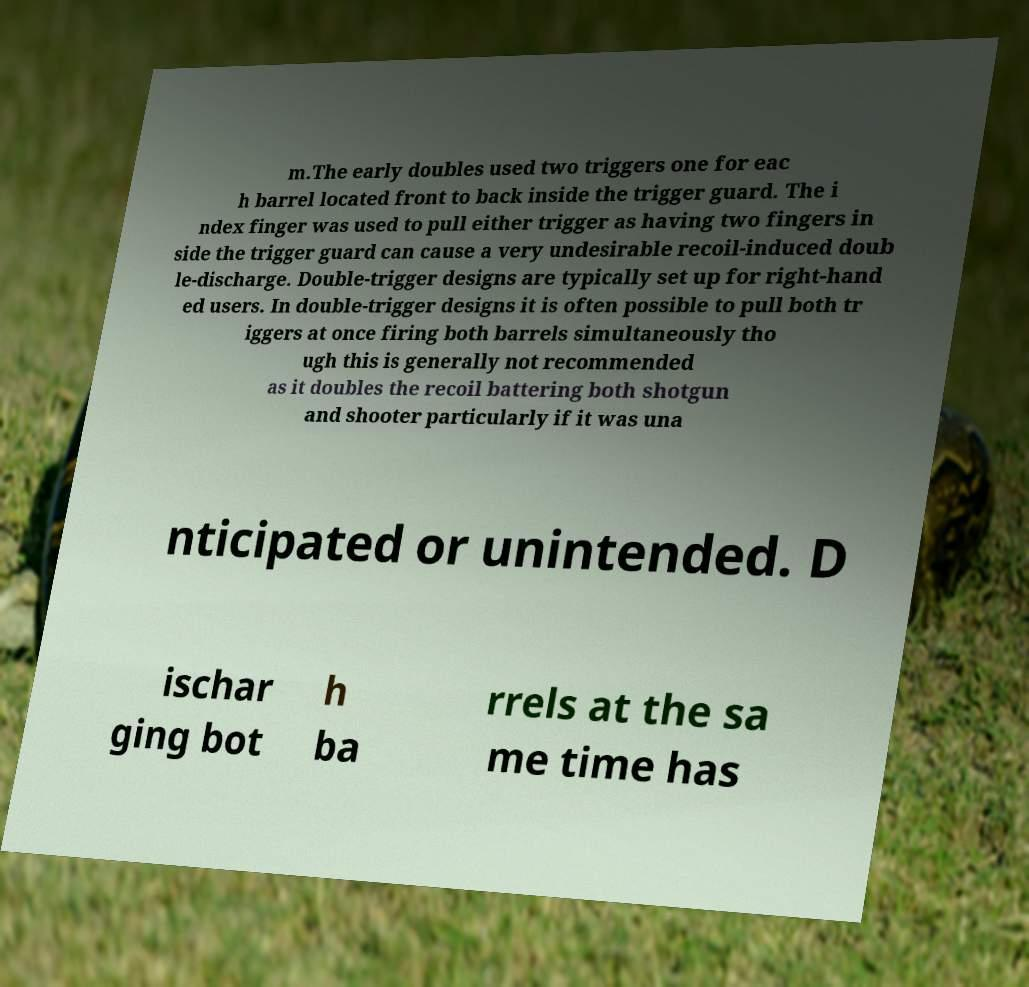Can you accurately transcribe the text from the provided image for me? m.The early doubles used two triggers one for eac h barrel located front to back inside the trigger guard. The i ndex finger was used to pull either trigger as having two fingers in side the trigger guard can cause a very undesirable recoil-induced doub le-discharge. Double-trigger designs are typically set up for right-hand ed users. In double-trigger designs it is often possible to pull both tr iggers at once firing both barrels simultaneously tho ugh this is generally not recommended as it doubles the recoil battering both shotgun and shooter particularly if it was una nticipated or unintended. D ischar ging bot h ba rrels at the sa me time has 